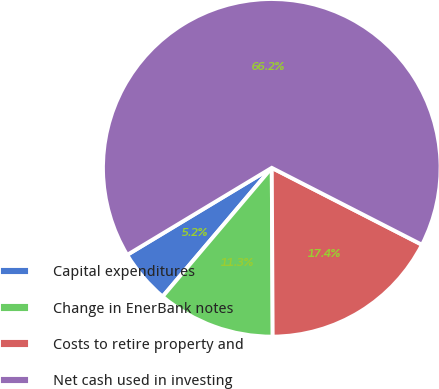<chart> <loc_0><loc_0><loc_500><loc_500><pie_chart><fcel>Capital expenditures<fcel>Change in EnerBank notes<fcel>Costs to retire property and<fcel>Net cash used in investing<nl><fcel>5.18%<fcel>11.28%<fcel>17.38%<fcel>66.16%<nl></chart> 